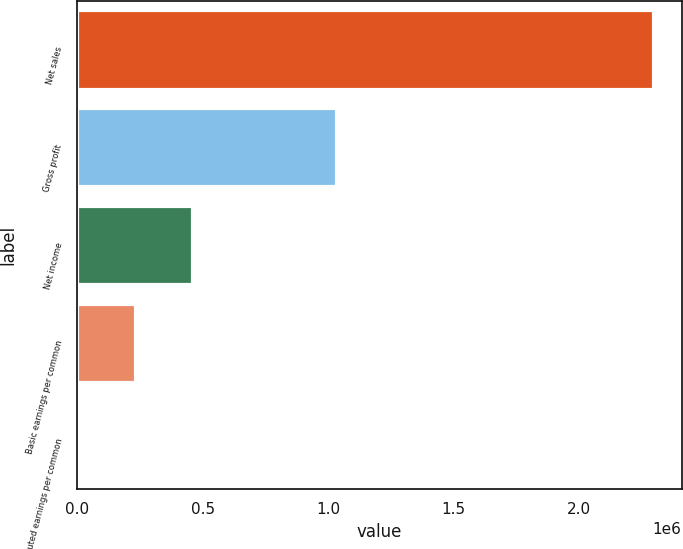Convert chart. <chart><loc_0><loc_0><loc_500><loc_500><bar_chart><fcel>Net sales<fcel>Gross profit<fcel>Net income<fcel>Basic earnings per common<fcel>Diluted earnings per common<nl><fcel>2.2952e+06<fcel>1.03239e+06<fcel>459042<fcel>229522<fcel>1.63<nl></chart> 